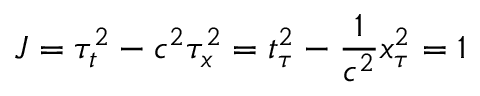Convert formula to latex. <formula><loc_0><loc_0><loc_500><loc_500>J = \tau _ { t } ^ { 2 } - c ^ { 2 } \tau _ { x } ^ { 2 } = t _ { \tau } ^ { 2 } - \frac { 1 } { c ^ { 2 } } x _ { \tau } ^ { 2 } = 1</formula> 